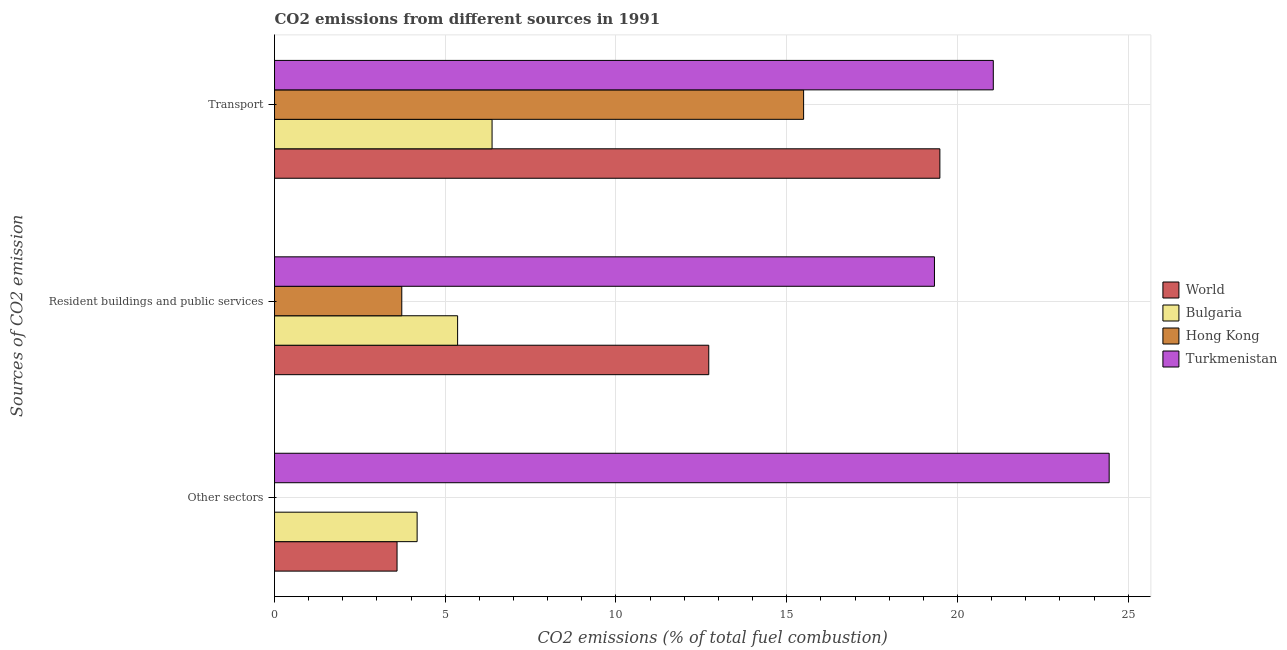How many different coloured bars are there?
Keep it short and to the point. 4. How many groups of bars are there?
Your answer should be very brief. 3. How many bars are there on the 1st tick from the top?
Ensure brevity in your answer.  4. How many bars are there on the 2nd tick from the bottom?
Your response must be concise. 4. What is the label of the 2nd group of bars from the top?
Ensure brevity in your answer.  Resident buildings and public services. What is the percentage of co2 emissions from other sectors in Turkmenistan?
Provide a short and direct response. 24.44. Across all countries, what is the maximum percentage of co2 emissions from resident buildings and public services?
Keep it short and to the point. 19.33. Across all countries, what is the minimum percentage of co2 emissions from transport?
Keep it short and to the point. 6.37. In which country was the percentage of co2 emissions from resident buildings and public services maximum?
Your answer should be compact. Turkmenistan. What is the total percentage of co2 emissions from transport in the graph?
Ensure brevity in your answer.  62.4. What is the difference between the percentage of co2 emissions from transport in Bulgaria and that in Hong Kong?
Make the answer very short. -9.12. What is the difference between the percentage of co2 emissions from transport in Hong Kong and the percentage of co2 emissions from resident buildings and public services in Bulgaria?
Keep it short and to the point. 10.13. What is the average percentage of co2 emissions from resident buildings and public services per country?
Provide a succinct answer. 10.28. What is the difference between the percentage of co2 emissions from transport and percentage of co2 emissions from resident buildings and public services in Bulgaria?
Offer a terse response. 1.01. In how many countries, is the percentage of co2 emissions from transport greater than 8 %?
Give a very brief answer. 3. What is the ratio of the percentage of co2 emissions from other sectors in World to that in Turkmenistan?
Provide a succinct answer. 0.15. What is the difference between the highest and the second highest percentage of co2 emissions from resident buildings and public services?
Provide a short and direct response. 6.61. What is the difference between the highest and the lowest percentage of co2 emissions from resident buildings and public services?
Ensure brevity in your answer.  15.6. Is the sum of the percentage of co2 emissions from other sectors in Turkmenistan and Bulgaria greater than the maximum percentage of co2 emissions from resident buildings and public services across all countries?
Ensure brevity in your answer.  Yes. How many bars are there?
Ensure brevity in your answer.  11. Are all the bars in the graph horizontal?
Your response must be concise. Yes. How many countries are there in the graph?
Ensure brevity in your answer.  4. How many legend labels are there?
Your answer should be very brief. 4. How are the legend labels stacked?
Keep it short and to the point. Vertical. What is the title of the graph?
Ensure brevity in your answer.  CO2 emissions from different sources in 1991. Does "Uzbekistan" appear as one of the legend labels in the graph?
Your response must be concise. No. What is the label or title of the X-axis?
Provide a short and direct response. CO2 emissions (% of total fuel combustion). What is the label or title of the Y-axis?
Ensure brevity in your answer.  Sources of CO2 emission. What is the CO2 emissions (% of total fuel combustion) in World in Other sectors?
Give a very brief answer. 3.59. What is the CO2 emissions (% of total fuel combustion) in Bulgaria in Other sectors?
Make the answer very short. 4.18. What is the CO2 emissions (% of total fuel combustion) of Turkmenistan in Other sectors?
Offer a terse response. 24.44. What is the CO2 emissions (% of total fuel combustion) in World in Resident buildings and public services?
Ensure brevity in your answer.  12.72. What is the CO2 emissions (% of total fuel combustion) in Bulgaria in Resident buildings and public services?
Keep it short and to the point. 5.36. What is the CO2 emissions (% of total fuel combustion) in Hong Kong in Resident buildings and public services?
Offer a very short reply. 3.73. What is the CO2 emissions (% of total fuel combustion) in Turkmenistan in Resident buildings and public services?
Offer a very short reply. 19.33. What is the CO2 emissions (% of total fuel combustion) of World in Transport?
Offer a terse response. 19.49. What is the CO2 emissions (% of total fuel combustion) of Bulgaria in Transport?
Your response must be concise. 6.37. What is the CO2 emissions (% of total fuel combustion) of Hong Kong in Transport?
Your response must be concise. 15.49. What is the CO2 emissions (% of total fuel combustion) in Turkmenistan in Transport?
Your answer should be compact. 21.05. Across all Sources of CO2 emission, what is the maximum CO2 emissions (% of total fuel combustion) of World?
Your response must be concise. 19.49. Across all Sources of CO2 emission, what is the maximum CO2 emissions (% of total fuel combustion) in Bulgaria?
Ensure brevity in your answer.  6.37. Across all Sources of CO2 emission, what is the maximum CO2 emissions (% of total fuel combustion) in Hong Kong?
Give a very brief answer. 15.49. Across all Sources of CO2 emission, what is the maximum CO2 emissions (% of total fuel combustion) of Turkmenistan?
Your response must be concise. 24.44. Across all Sources of CO2 emission, what is the minimum CO2 emissions (% of total fuel combustion) of World?
Offer a terse response. 3.59. Across all Sources of CO2 emission, what is the minimum CO2 emissions (% of total fuel combustion) of Bulgaria?
Keep it short and to the point. 4.18. Across all Sources of CO2 emission, what is the minimum CO2 emissions (% of total fuel combustion) in Turkmenistan?
Ensure brevity in your answer.  19.33. What is the total CO2 emissions (% of total fuel combustion) in World in the graph?
Your response must be concise. 35.79. What is the total CO2 emissions (% of total fuel combustion) of Bulgaria in the graph?
Make the answer very short. 15.91. What is the total CO2 emissions (% of total fuel combustion) in Hong Kong in the graph?
Your response must be concise. 19.22. What is the total CO2 emissions (% of total fuel combustion) of Turkmenistan in the graph?
Provide a succinct answer. 64.82. What is the difference between the CO2 emissions (% of total fuel combustion) of World in Other sectors and that in Resident buildings and public services?
Your answer should be compact. -9.13. What is the difference between the CO2 emissions (% of total fuel combustion) of Bulgaria in Other sectors and that in Resident buildings and public services?
Give a very brief answer. -1.19. What is the difference between the CO2 emissions (% of total fuel combustion) of Turkmenistan in Other sectors and that in Resident buildings and public services?
Your response must be concise. 5.12. What is the difference between the CO2 emissions (% of total fuel combustion) of World in Other sectors and that in Transport?
Make the answer very short. -15.9. What is the difference between the CO2 emissions (% of total fuel combustion) in Bulgaria in Other sectors and that in Transport?
Provide a succinct answer. -2.19. What is the difference between the CO2 emissions (% of total fuel combustion) in Turkmenistan in Other sectors and that in Transport?
Offer a very short reply. 3.39. What is the difference between the CO2 emissions (% of total fuel combustion) of World in Resident buildings and public services and that in Transport?
Make the answer very short. -6.77. What is the difference between the CO2 emissions (% of total fuel combustion) of Bulgaria in Resident buildings and public services and that in Transport?
Your response must be concise. -1.01. What is the difference between the CO2 emissions (% of total fuel combustion) in Hong Kong in Resident buildings and public services and that in Transport?
Ensure brevity in your answer.  -11.77. What is the difference between the CO2 emissions (% of total fuel combustion) in Turkmenistan in Resident buildings and public services and that in Transport?
Offer a terse response. -1.72. What is the difference between the CO2 emissions (% of total fuel combustion) in World in Other sectors and the CO2 emissions (% of total fuel combustion) in Bulgaria in Resident buildings and public services?
Provide a succinct answer. -1.77. What is the difference between the CO2 emissions (% of total fuel combustion) of World in Other sectors and the CO2 emissions (% of total fuel combustion) of Hong Kong in Resident buildings and public services?
Make the answer very short. -0.14. What is the difference between the CO2 emissions (% of total fuel combustion) in World in Other sectors and the CO2 emissions (% of total fuel combustion) in Turkmenistan in Resident buildings and public services?
Offer a very short reply. -15.74. What is the difference between the CO2 emissions (% of total fuel combustion) in Bulgaria in Other sectors and the CO2 emissions (% of total fuel combustion) in Hong Kong in Resident buildings and public services?
Keep it short and to the point. 0.45. What is the difference between the CO2 emissions (% of total fuel combustion) of Bulgaria in Other sectors and the CO2 emissions (% of total fuel combustion) of Turkmenistan in Resident buildings and public services?
Provide a short and direct response. -15.15. What is the difference between the CO2 emissions (% of total fuel combustion) in World in Other sectors and the CO2 emissions (% of total fuel combustion) in Bulgaria in Transport?
Make the answer very short. -2.78. What is the difference between the CO2 emissions (% of total fuel combustion) of World in Other sectors and the CO2 emissions (% of total fuel combustion) of Hong Kong in Transport?
Offer a terse response. -11.91. What is the difference between the CO2 emissions (% of total fuel combustion) of World in Other sectors and the CO2 emissions (% of total fuel combustion) of Turkmenistan in Transport?
Provide a succinct answer. -17.46. What is the difference between the CO2 emissions (% of total fuel combustion) in Bulgaria in Other sectors and the CO2 emissions (% of total fuel combustion) in Hong Kong in Transport?
Your answer should be very brief. -11.32. What is the difference between the CO2 emissions (% of total fuel combustion) of Bulgaria in Other sectors and the CO2 emissions (% of total fuel combustion) of Turkmenistan in Transport?
Provide a short and direct response. -16.87. What is the difference between the CO2 emissions (% of total fuel combustion) in World in Resident buildings and public services and the CO2 emissions (% of total fuel combustion) in Bulgaria in Transport?
Give a very brief answer. 6.35. What is the difference between the CO2 emissions (% of total fuel combustion) of World in Resident buildings and public services and the CO2 emissions (% of total fuel combustion) of Hong Kong in Transport?
Provide a succinct answer. -2.78. What is the difference between the CO2 emissions (% of total fuel combustion) in World in Resident buildings and public services and the CO2 emissions (% of total fuel combustion) in Turkmenistan in Transport?
Provide a succinct answer. -8.33. What is the difference between the CO2 emissions (% of total fuel combustion) of Bulgaria in Resident buildings and public services and the CO2 emissions (% of total fuel combustion) of Hong Kong in Transport?
Your response must be concise. -10.13. What is the difference between the CO2 emissions (% of total fuel combustion) in Bulgaria in Resident buildings and public services and the CO2 emissions (% of total fuel combustion) in Turkmenistan in Transport?
Ensure brevity in your answer.  -15.69. What is the difference between the CO2 emissions (% of total fuel combustion) of Hong Kong in Resident buildings and public services and the CO2 emissions (% of total fuel combustion) of Turkmenistan in Transport?
Make the answer very short. -17.32. What is the average CO2 emissions (% of total fuel combustion) of World per Sources of CO2 emission?
Keep it short and to the point. 11.93. What is the average CO2 emissions (% of total fuel combustion) in Bulgaria per Sources of CO2 emission?
Make the answer very short. 5.3. What is the average CO2 emissions (% of total fuel combustion) of Hong Kong per Sources of CO2 emission?
Provide a succinct answer. 6.41. What is the average CO2 emissions (% of total fuel combustion) in Turkmenistan per Sources of CO2 emission?
Your answer should be compact. 21.61. What is the difference between the CO2 emissions (% of total fuel combustion) in World and CO2 emissions (% of total fuel combustion) in Bulgaria in Other sectors?
Your answer should be compact. -0.59. What is the difference between the CO2 emissions (% of total fuel combustion) in World and CO2 emissions (% of total fuel combustion) in Turkmenistan in Other sectors?
Offer a terse response. -20.86. What is the difference between the CO2 emissions (% of total fuel combustion) in Bulgaria and CO2 emissions (% of total fuel combustion) in Turkmenistan in Other sectors?
Provide a succinct answer. -20.27. What is the difference between the CO2 emissions (% of total fuel combustion) in World and CO2 emissions (% of total fuel combustion) in Bulgaria in Resident buildings and public services?
Ensure brevity in your answer.  7.36. What is the difference between the CO2 emissions (% of total fuel combustion) in World and CO2 emissions (% of total fuel combustion) in Hong Kong in Resident buildings and public services?
Your answer should be compact. 8.99. What is the difference between the CO2 emissions (% of total fuel combustion) of World and CO2 emissions (% of total fuel combustion) of Turkmenistan in Resident buildings and public services?
Offer a terse response. -6.61. What is the difference between the CO2 emissions (% of total fuel combustion) in Bulgaria and CO2 emissions (% of total fuel combustion) in Hong Kong in Resident buildings and public services?
Your answer should be compact. 1.64. What is the difference between the CO2 emissions (% of total fuel combustion) of Bulgaria and CO2 emissions (% of total fuel combustion) of Turkmenistan in Resident buildings and public services?
Offer a very short reply. -13.96. What is the difference between the CO2 emissions (% of total fuel combustion) of Hong Kong and CO2 emissions (% of total fuel combustion) of Turkmenistan in Resident buildings and public services?
Provide a short and direct response. -15.6. What is the difference between the CO2 emissions (% of total fuel combustion) of World and CO2 emissions (% of total fuel combustion) of Bulgaria in Transport?
Your response must be concise. 13.12. What is the difference between the CO2 emissions (% of total fuel combustion) in World and CO2 emissions (% of total fuel combustion) in Hong Kong in Transport?
Your answer should be compact. 3.99. What is the difference between the CO2 emissions (% of total fuel combustion) in World and CO2 emissions (% of total fuel combustion) in Turkmenistan in Transport?
Provide a succinct answer. -1.56. What is the difference between the CO2 emissions (% of total fuel combustion) of Bulgaria and CO2 emissions (% of total fuel combustion) of Hong Kong in Transport?
Offer a very short reply. -9.12. What is the difference between the CO2 emissions (% of total fuel combustion) of Bulgaria and CO2 emissions (% of total fuel combustion) of Turkmenistan in Transport?
Offer a terse response. -14.68. What is the difference between the CO2 emissions (% of total fuel combustion) in Hong Kong and CO2 emissions (% of total fuel combustion) in Turkmenistan in Transport?
Offer a very short reply. -5.56. What is the ratio of the CO2 emissions (% of total fuel combustion) in World in Other sectors to that in Resident buildings and public services?
Your answer should be very brief. 0.28. What is the ratio of the CO2 emissions (% of total fuel combustion) of Bulgaria in Other sectors to that in Resident buildings and public services?
Offer a very short reply. 0.78. What is the ratio of the CO2 emissions (% of total fuel combustion) of Turkmenistan in Other sectors to that in Resident buildings and public services?
Offer a very short reply. 1.26. What is the ratio of the CO2 emissions (% of total fuel combustion) of World in Other sectors to that in Transport?
Your answer should be very brief. 0.18. What is the ratio of the CO2 emissions (% of total fuel combustion) of Bulgaria in Other sectors to that in Transport?
Keep it short and to the point. 0.66. What is the ratio of the CO2 emissions (% of total fuel combustion) in Turkmenistan in Other sectors to that in Transport?
Provide a succinct answer. 1.16. What is the ratio of the CO2 emissions (% of total fuel combustion) in World in Resident buildings and public services to that in Transport?
Make the answer very short. 0.65. What is the ratio of the CO2 emissions (% of total fuel combustion) in Bulgaria in Resident buildings and public services to that in Transport?
Your answer should be very brief. 0.84. What is the ratio of the CO2 emissions (% of total fuel combustion) of Hong Kong in Resident buildings and public services to that in Transport?
Provide a succinct answer. 0.24. What is the ratio of the CO2 emissions (% of total fuel combustion) of Turkmenistan in Resident buildings and public services to that in Transport?
Provide a succinct answer. 0.92. What is the difference between the highest and the second highest CO2 emissions (% of total fuel combustion) in World?
Offer a very short reply. 6.77. What is the difference between the highest and the second highest CO2 emissions (% of total fuel combustion) in Bulgaria?
Ensure brevity in your answer.  1.01. What is the difference between the highest and the second highest CO2 emissions (% of total fuel combustion) of Turkmenistan?
Your answer should be compact. 3.39. What is the difference between the highest and the lowest CO2 emissions (% of total fuel combustion) of World?
Your answer should be compact. 15.9. What is the difference between the highest and the lowest CO2 emissions (% of total fuel combustion) in Bulgaria?
Keep it short and to the point. 2.19. What is the difference between the highest and the lowest CO2 emissions (% of total fuel combustion) of Hong Kong?
Give a very brief answer. 15.49. What is the difference between the highest and the lowest CO2 emissions (% of total fuel combustion) in Turkmenistan?
Give a very brief answer. 5.12. 